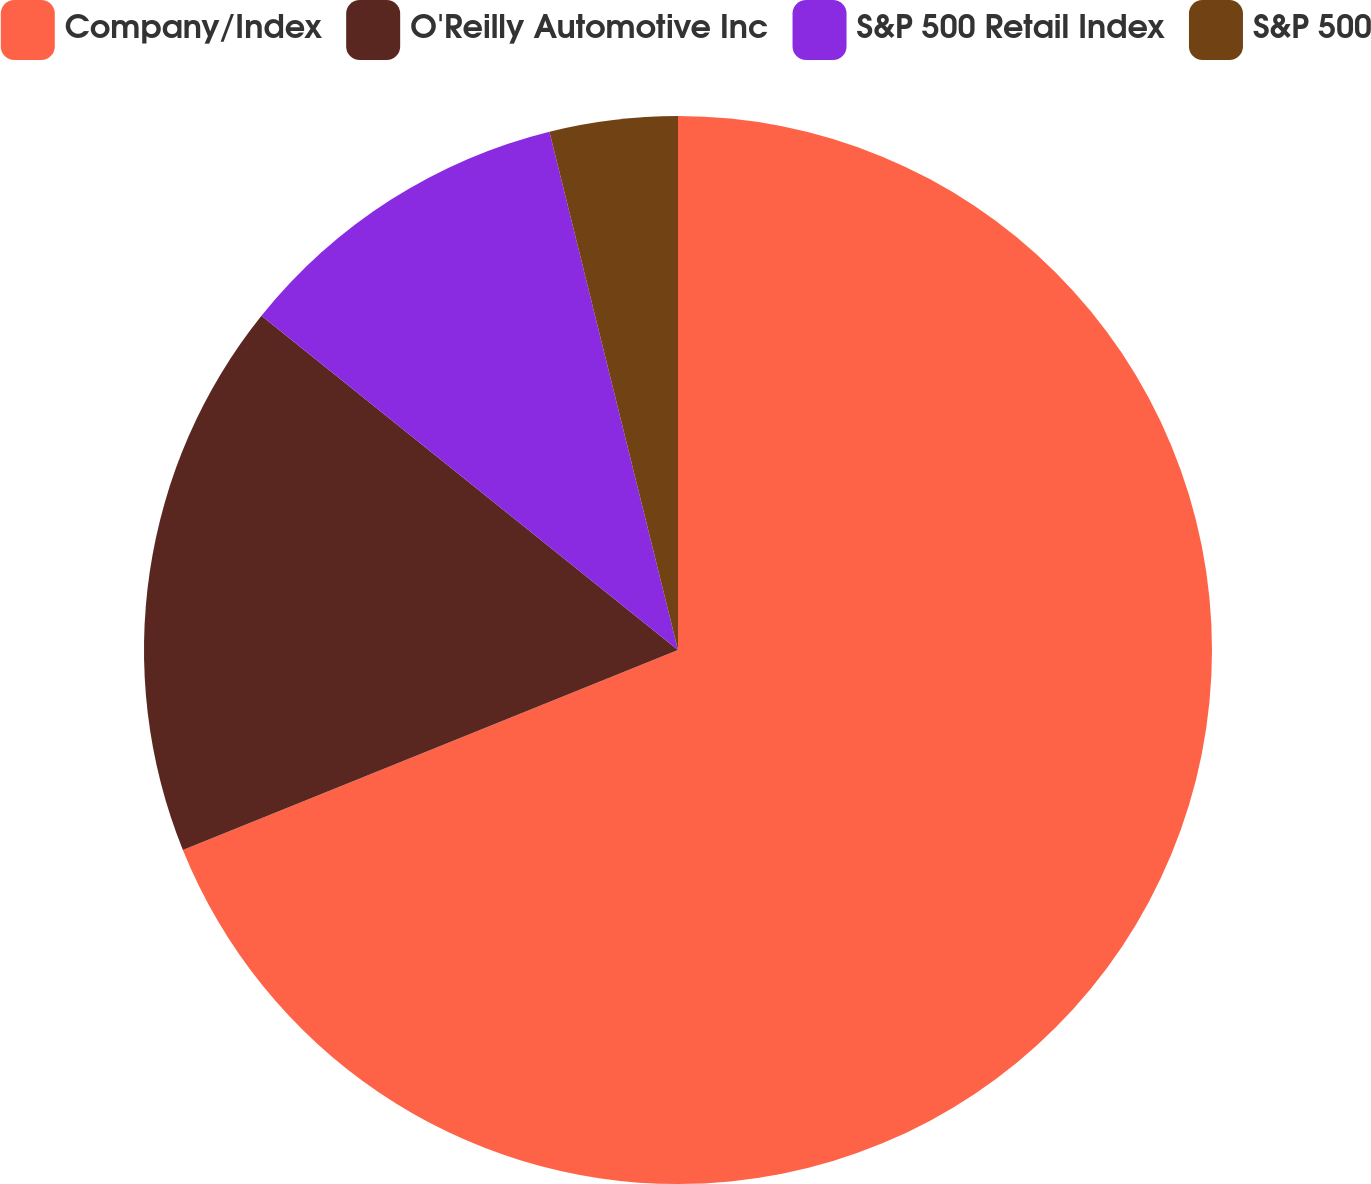<chart> <loc_0><loc_0><loc_500><loc_500><pie_chart><fcel>Company/Index<fcel>O'Reilly Automotive Inc<fcel>S&P 500 Retail Index<fcel>S&P 500<nl><fcel>68.89%<fcel>16.87%<fcel>10.37%<fcel>3.87%<nl></chart> 